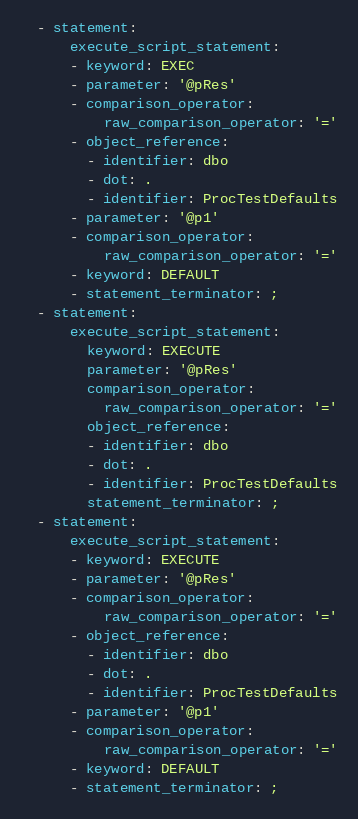Convert code to text. <code><loc_0><loc_0><loc_500><loc_500><_YAML_>  - statement:
      execute_script_statement:
      - keyword: EXEC
      - parameter: '@pRes'
      - comparison_operator:
          raw_comparison_operator: '='
      - object_reference:
        - identifier: dbo
        - dot: .
        - identifier: ProcTestDefaults
      - parameter: '@p1'
      - comparison_operator:
          raw_comparison_operator: '='
      - keyword: DEFAULT
      - statement_terminator: ;
  - statement:
      execute_script_statement:
        keyword: EXECUTE
        parameter: '@pRes'
        comparison_operator:
          raw_comparison_operator: '='
        object_reference:
        - identifier: dbo
        - dot: .
        - identifier: ProcTestDefaults
        statement_terminator: ;
  - statement:
      execute_script_statement:
      - keyword: EXECUTE
      - parameter: '@pRes'
      - comparison_operator:
          raw_comparison_operator: '='
      - object_reference:
        - identifier: dbo
        - dot: .
        - identifier: ProcTestDefaults
      - parameter: '@p1'
      - comparison_operator:
          raw_comparison_operator: '='
      - keyword: DEFAULT
      - statement_terminator: ;
</code> 